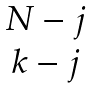<formula> <loc_0><loc_0><loc_500><loc_500>\begin{matrix} N - j \\ k - j \end{matrix}</formula> 